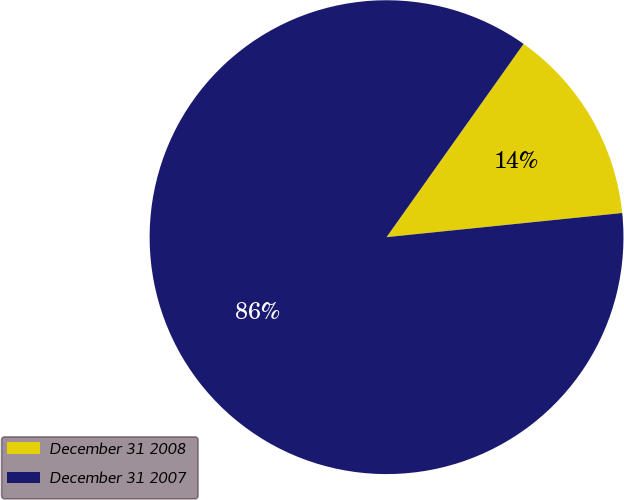<chart> <loc_0><loc_0><loc_500><loc_500><pie_chart><fcel>December 31 2008<fcel>December 31 2007<nl><fcel>13.56%<fcel>86.44%<nl></chart> 